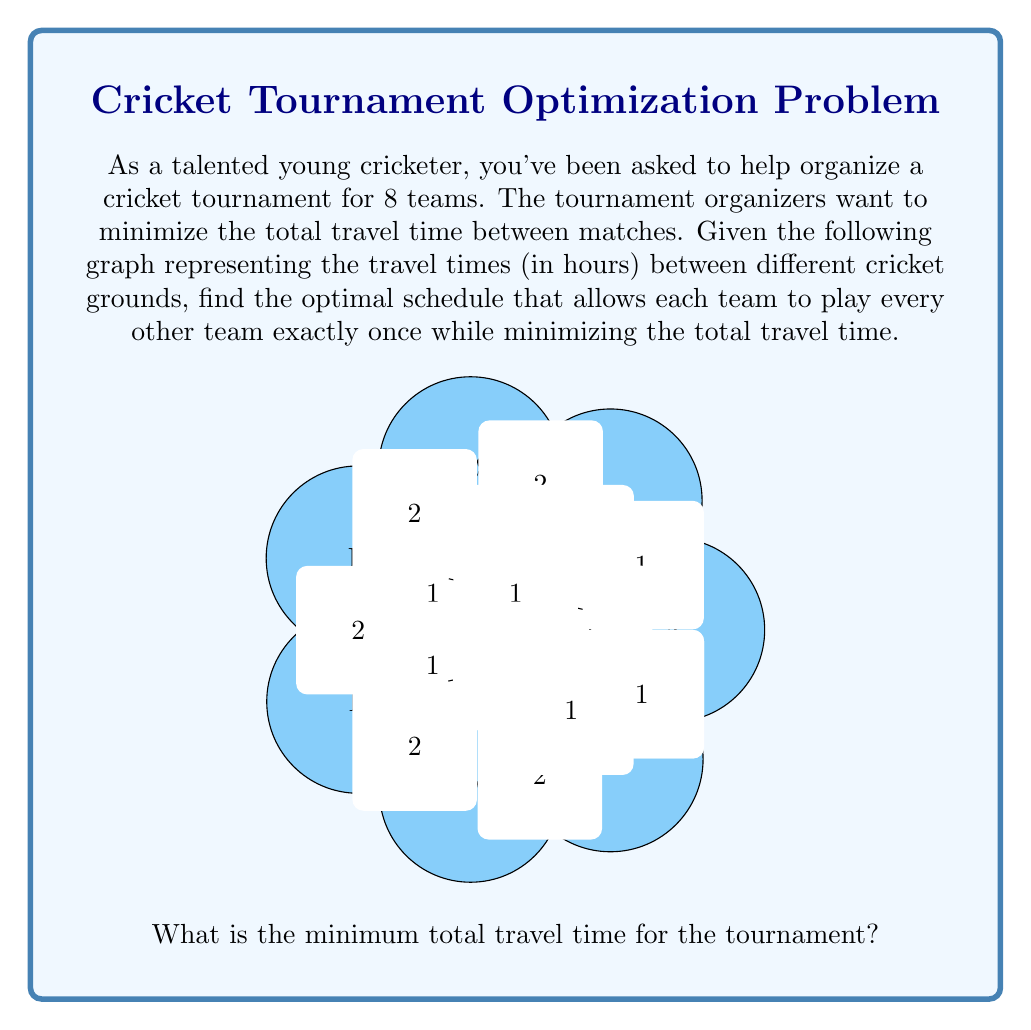What is the answer to this math problem? To solve this problem, we need to find the minimum spanning tree (MST) of the given graph. The MST will give us the optimal schedule that minimizes the total travel time.

We can use Kruskal's algorithm to find the MST:

1) Sort all edges in ascending order of weight (travel time):
   AB(1), AG(1), AH(1), BH(1), CH(1), DH(1), EH(1), AC(1), AD(1), AF(1), AE(2), BC(2), CD(2), DE(2), EF(2), FG(2)

2) Start with an empty set of edges and add edges one by one, skipping those that would create a cycle:

   AB(1) - Add
   AG(1) - Add
   AH(1) - Add
   BH(1) - Skip (would create cycle ABH)
   CH(1) - Add
   DH(1) - Add
   EH(1) - Add
   AC(1) - Skip (would create cycle ACH)
   AD(1) - Skip (would create cycle ADH)
   AF(1) - Add
   AE(2) - Skip (would create cycle AEH)

3) We stop here as we have added 7 edges, which is sufficient for a MST of an 8-vertex graph.

The resulting MST has edges: AB, AG, AH, CH, DH, EH, AF

The total weight (travel time) of this MST is:
$$1 + 1 + 1 + 1 + 1 + 1 + 1 = 7$$

This MST represents the optimal schedule for the tournament. Each edge in the MST represents a match between two teams, and the total weight represents the minimum total travel time.
Answer: 7 hours 